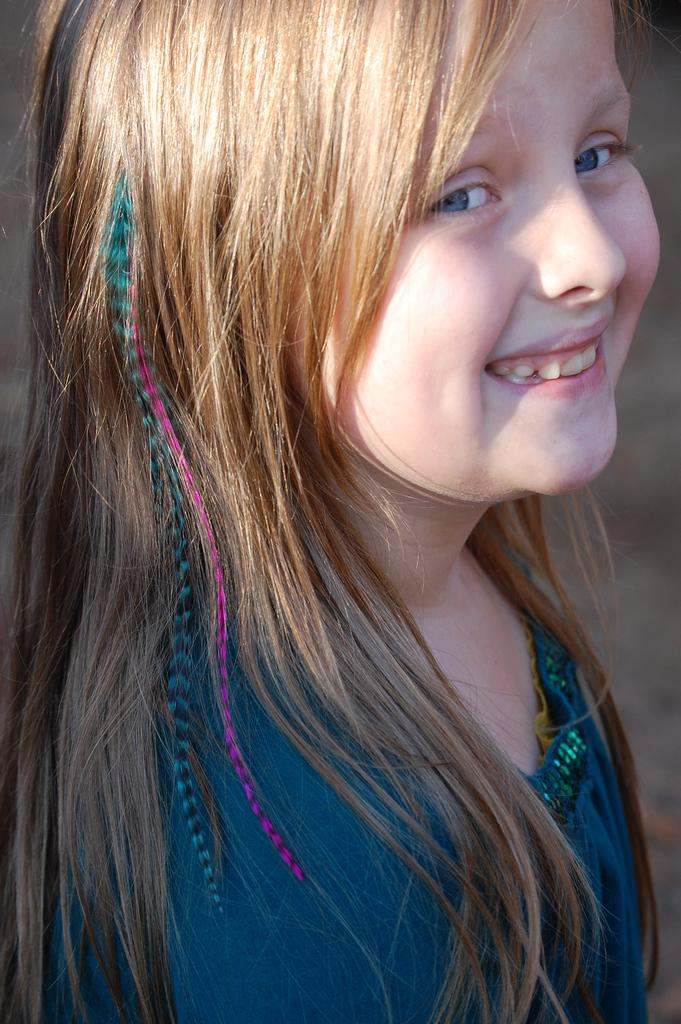Who is present in the image? There is a girl in the image. How many goldfish are swimming in the background of the image? There are no goldfish present in the image; it only features a girl. What type of furniture is visible in the image? There is no furniture visible in the image; it only features a girl. 